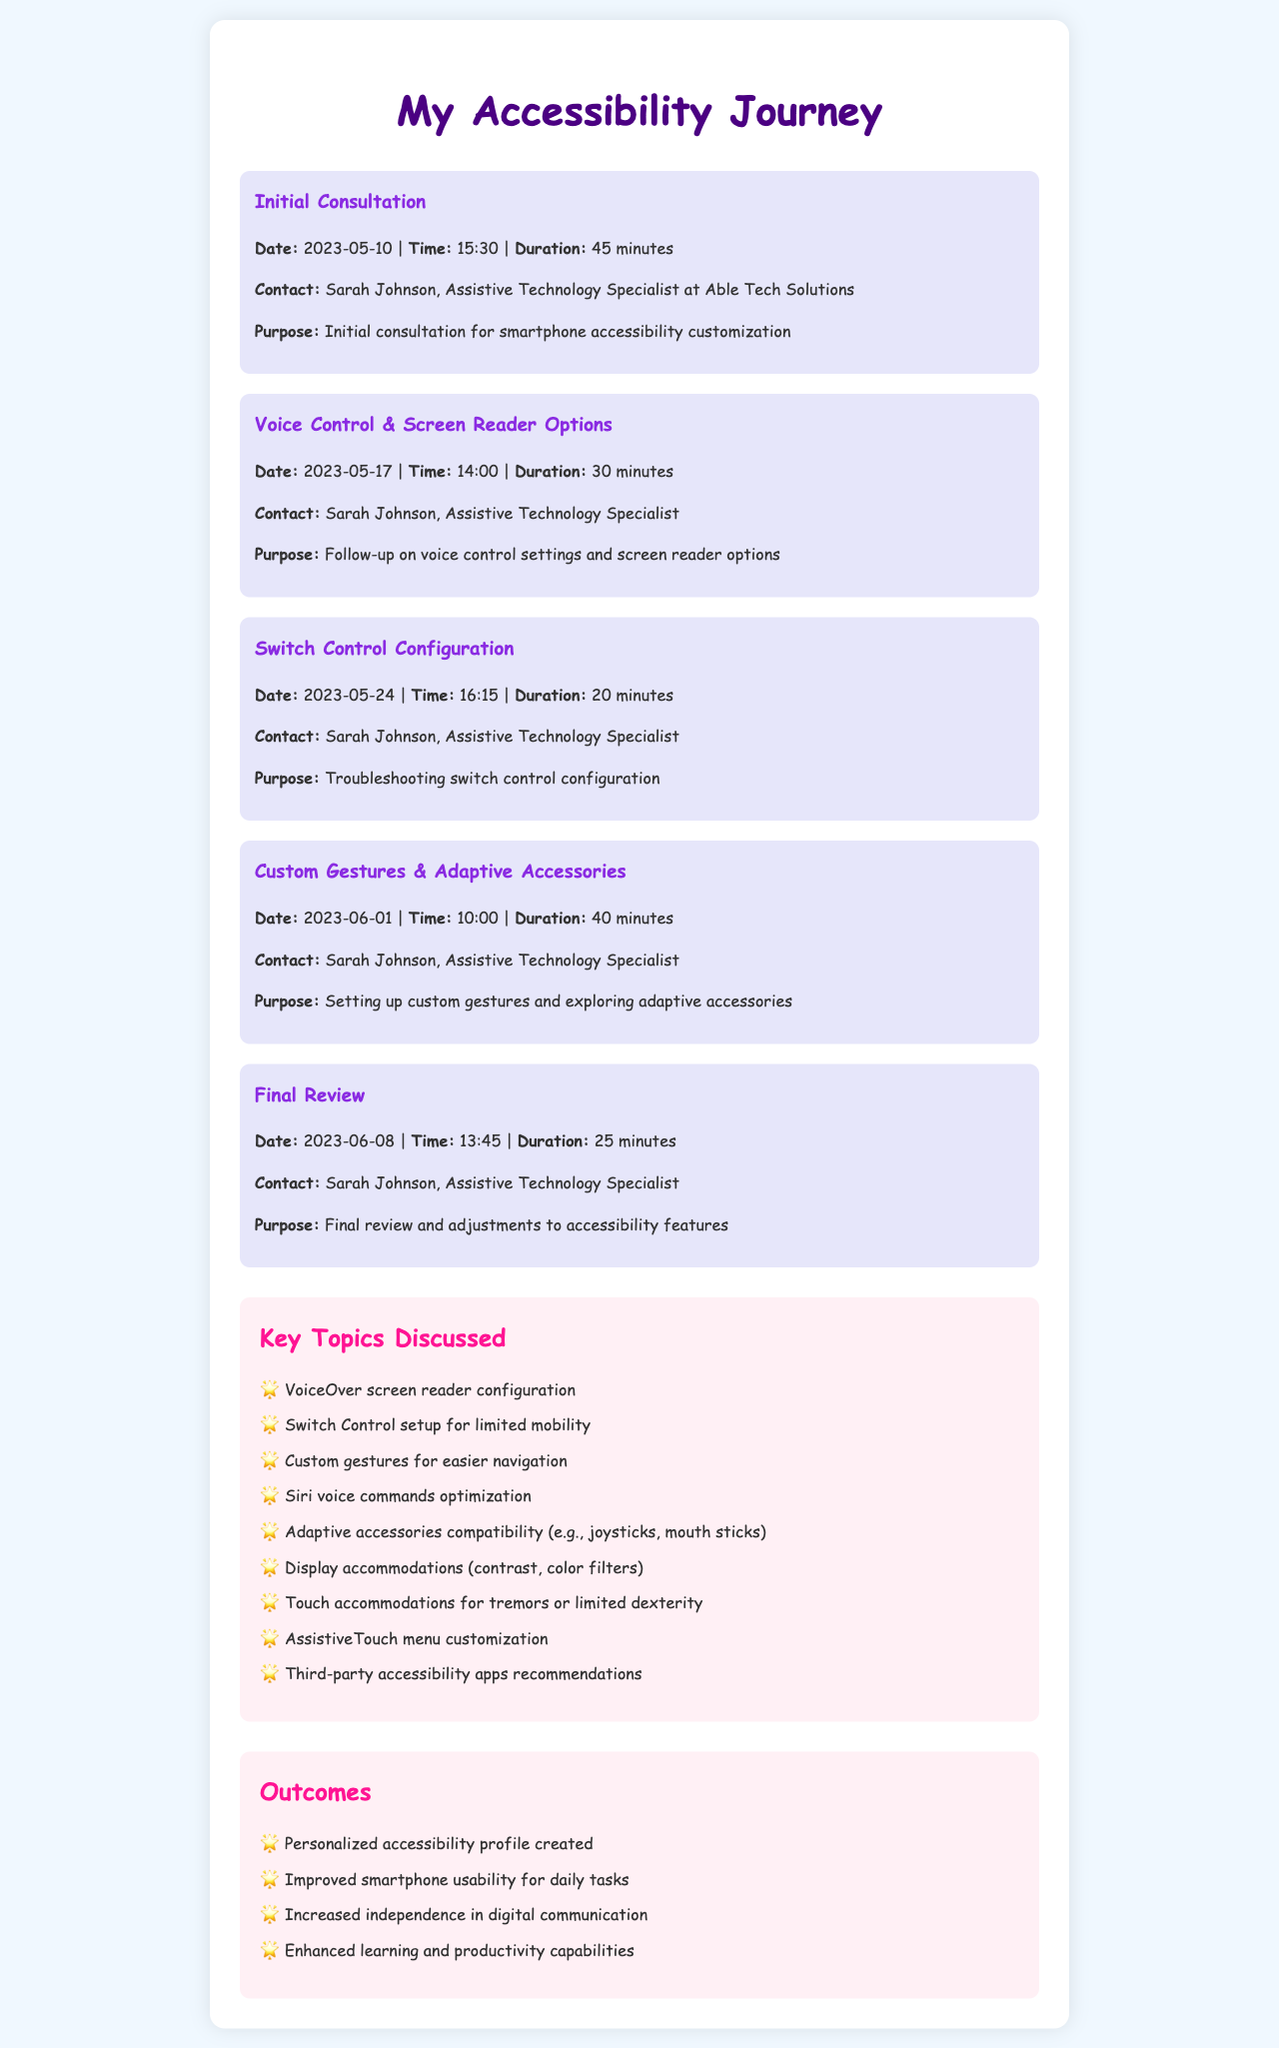What is the name of the assistive technology specialist? The document mentions Sarah Johnson as the assistive technology specialist for Able Tech Solutions.
Answer: Sarah Johnson When was the initial consultation held? The initial consultation date is provided in the document as 2023-05-10.
Answer: 2023-05-10 How long was the call about voice control settings? The duration for the voice control settings call is stated as 30 minutes.
Answer: 30 minutes What is one topic discussed related to screen reader options? The document lists VoiceOver screen reader configuration as a topic discussed.
Answer: VoiceOver screen reader configuration What was the purpose of the final review call? The purpose of the final review call is described in the document as adjustments to accessibility features.
Answer: Final review and adjustments to accessibility features How many calls were made in total? The document details a total of five calls regarding accessibility features.
Answer: 5 Which date was dedicated to setting up custom gestures? The document specifies that the call for setting up custom gestures took place on 2023-06-01.
Answer: 2023-06-01 What outcome involves increased independence? One of the listed outcomes states increased independence in digital communication.
Answer: Increased independence in digital communication What type of customization was discussed on 2023-05-24? The document indicates that troubleshooting switch control configuration was the focus of that call.
Answer: Switch control configuration 